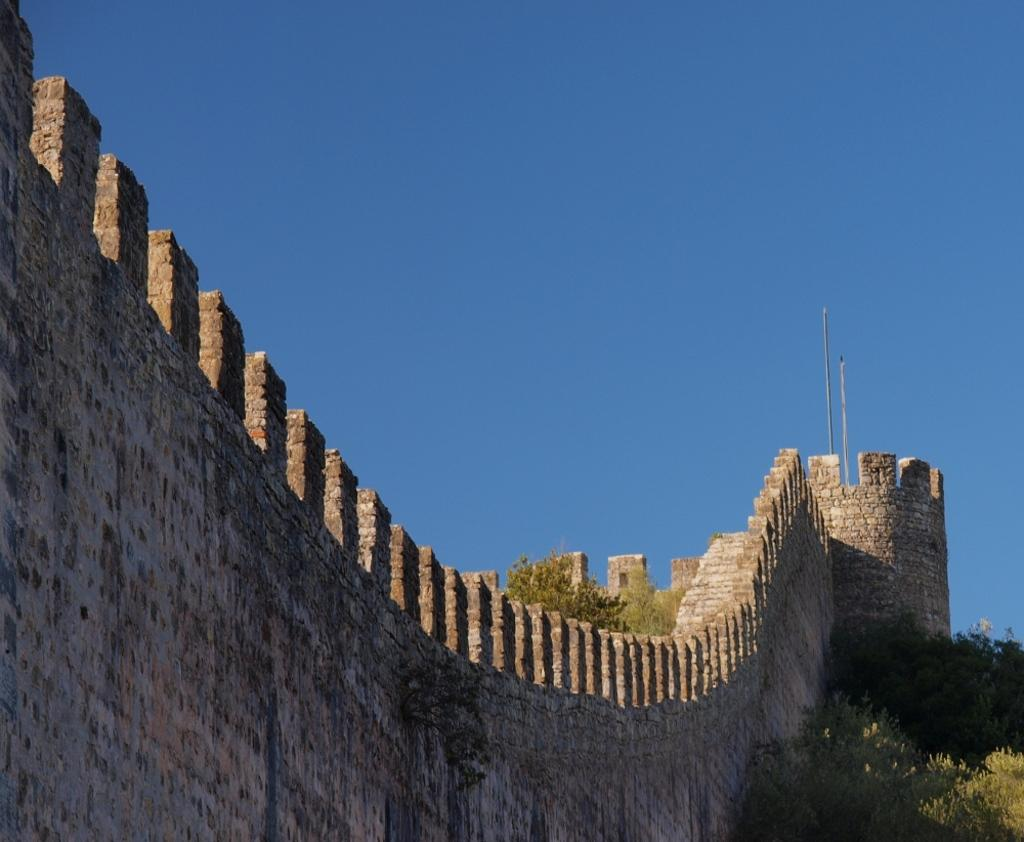What is located on the left side of the image? There are trees on the left side of the image. What is located on the right side of the image? There are trees on the right side of the image. What is the background of the image? The background of the image includes a wall and trees on both sides. What is visible at the top of the image? The sky is visible at the top of the image. How do the plants in the image maintain their balance? There are no plants mentioned in the image; it only includes trees and a wall. What type of pull can be seen in the image? There is no pull present in the image. 